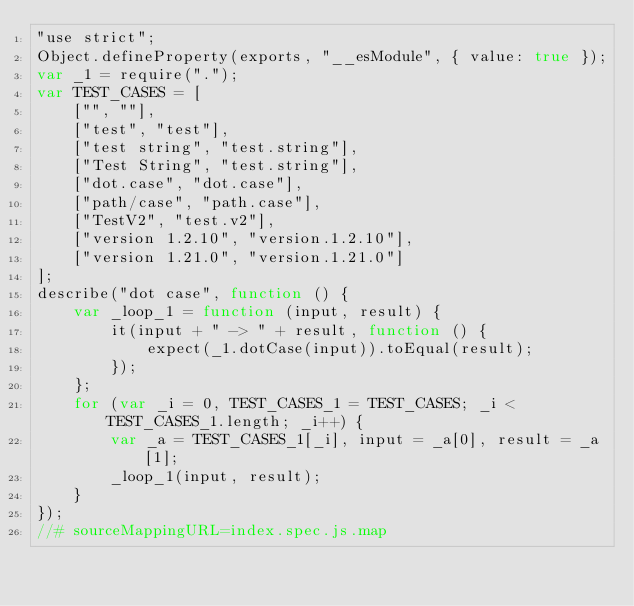<code> <loc_0><loc_0><loc_500><loc_500><_JavaScript_>"use strict";
Object.defineProperty(exports, "__esModule", { value: true });
var _1 = require(".");
var TEST_CASES = [
    ["", ""],
    ["test", "test"],
    ["test string", "test.string"],
    ["Test String", "test.string"],
    ["dot.case", "dot.case"],
    ["path/case", "path.case"],
    ["TestV2", "test.v2"],
    ["version 1.2.10", "version.1.2.10"],
    ["version 1.21.0", "version.1.21.0"]
];
describe("dot case", function () {
    var _loop_1 = function (input, result) {
        it(input + " -> " + result, function () {
            expect(_1.dotCase(input)).toEqual(result);
        });
    };
    for (var _i = 0, TEST_CASES_1 = TEST_CASES; _i < TEST_CASES_1.length; _i++) {
        var _a = TEST_CASES_1[_i], input = _a[0], result = _a[1];
        _loop_1(input, result);
    }
});
//# sourceMappingURL=index.spec.js.map</code> 